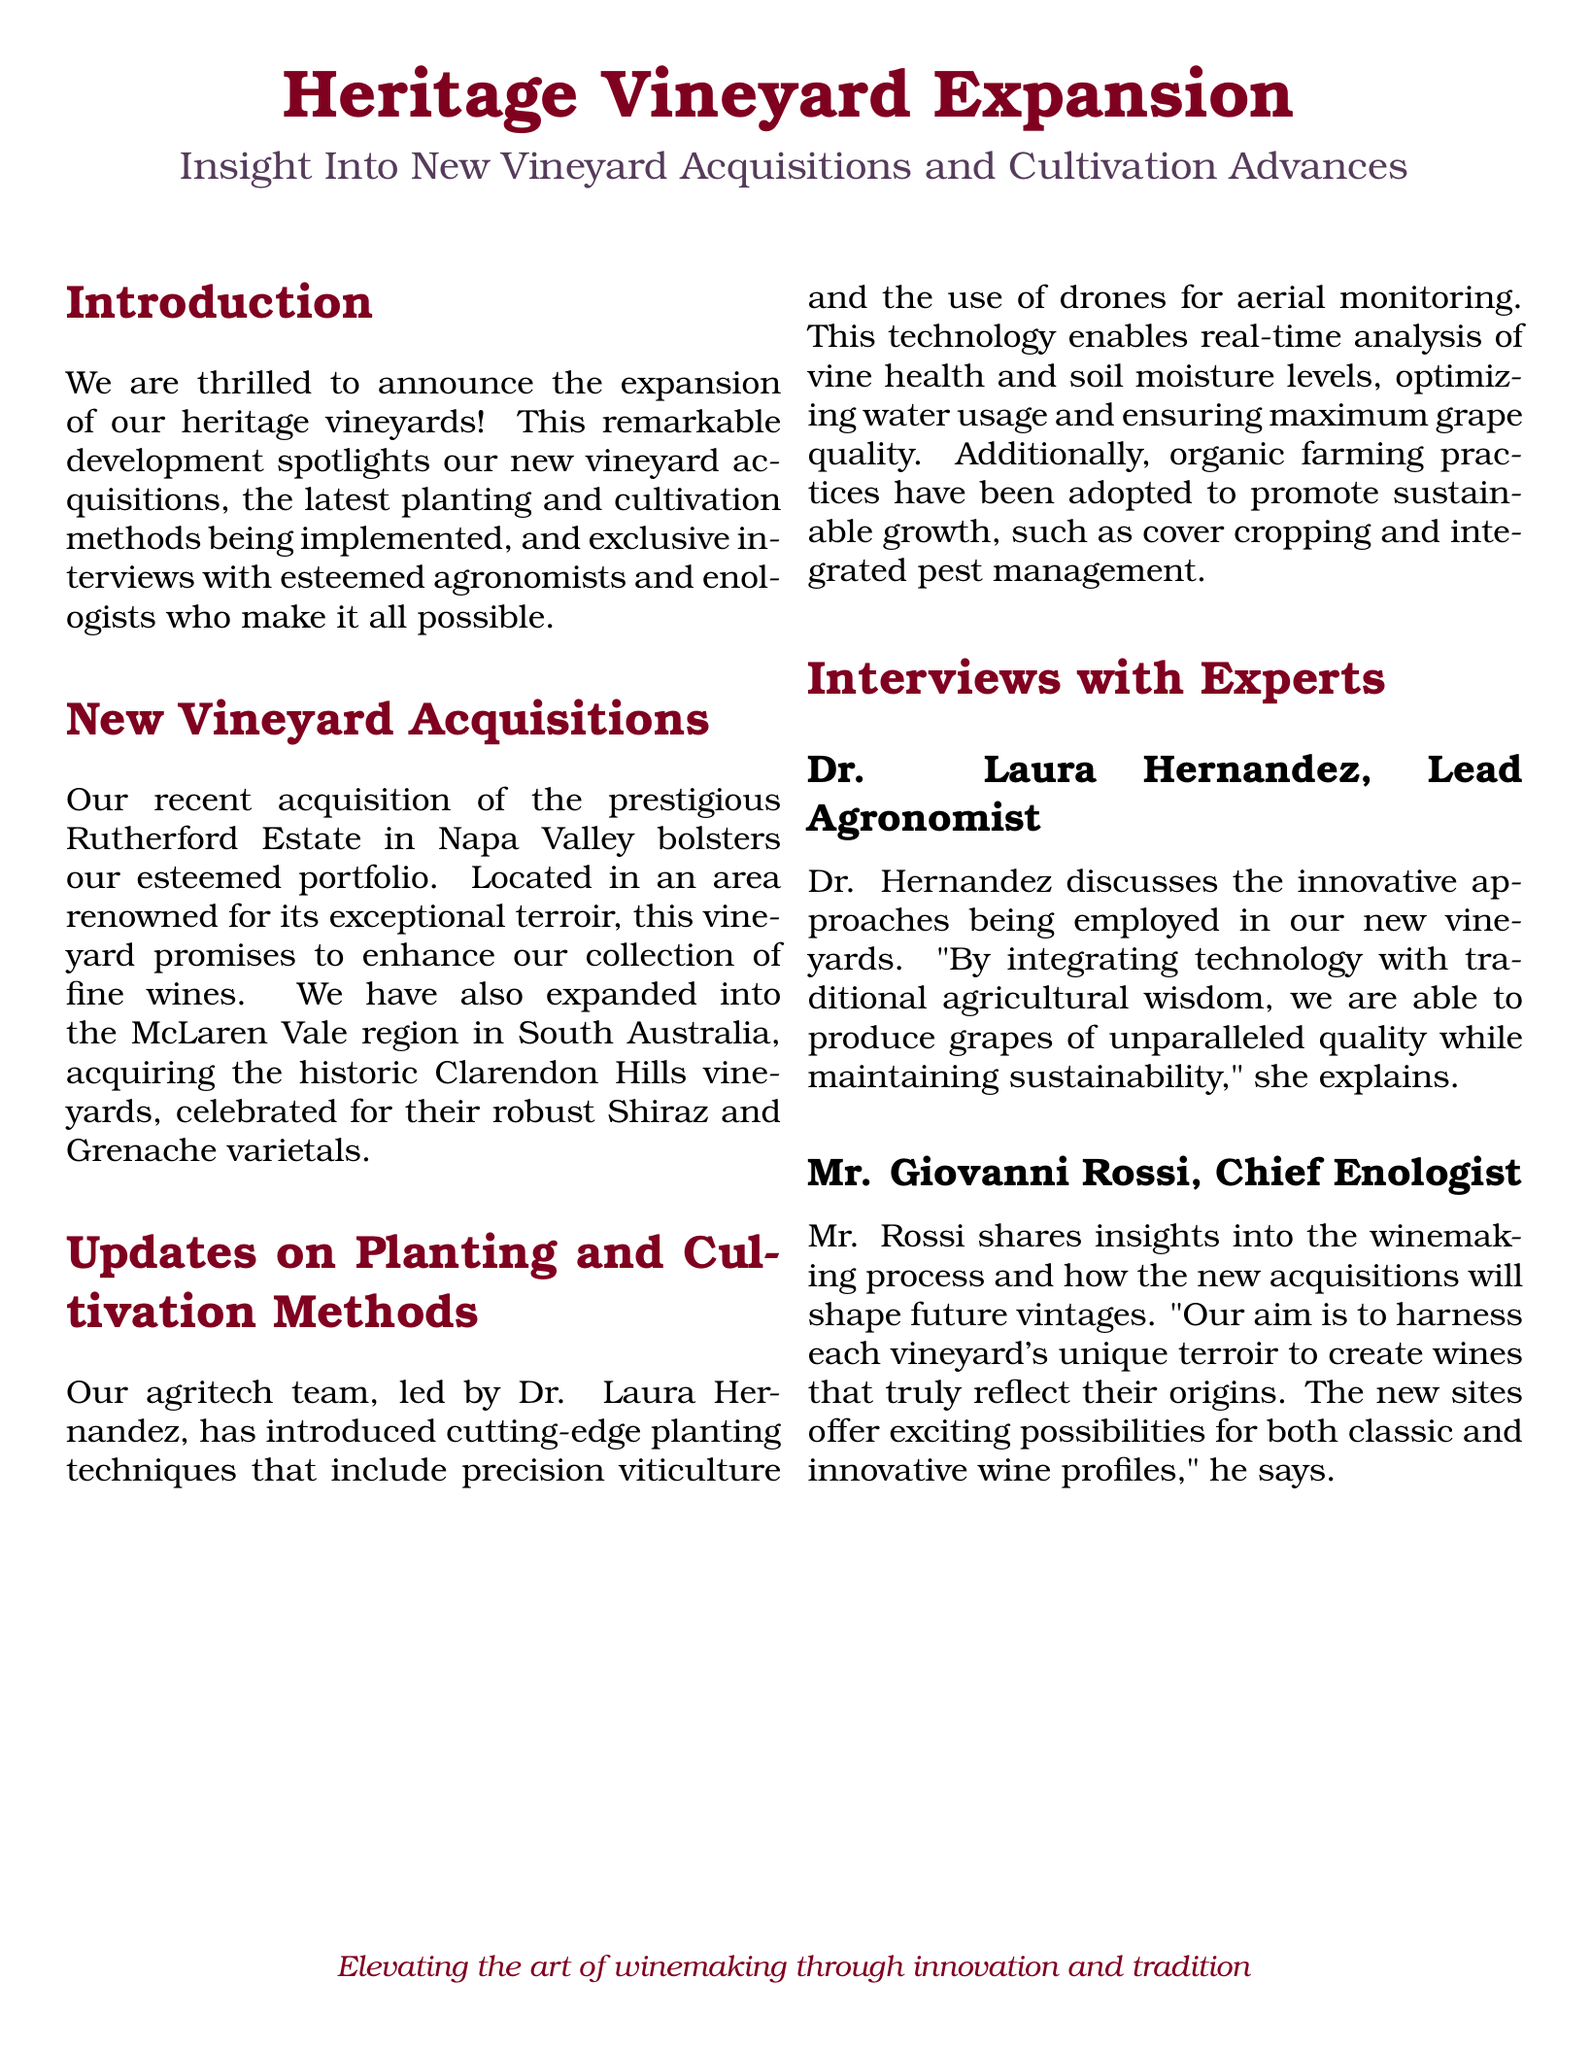What is the name of the recently acquired vineyard in Napa Valley? The document mentions the acquisition of the Rutherford Estate in Napa Valley.
Answer: Rutherford Estate Who is the Lead Agronomist mentioned in the document? The document identifies Dr. Laura Hernandez as the Lead Agronomist.
Answer: Dr. Laura Hernandez What farming practices have been adopted to promote sustainable growth? The document states that organic farming practices such as cover cropping and integrated pest management have been adopted.
Answer: Organic farming practices Which region is home to the newly acquired Clarendon Hills vineyards? The document states that the Clarendon Hills vineyards are located in the McLaren Vale region in South Australia.
Answer: McLaren Vale What technology is being used for aerial monitoring in the new vineyards? The document mentions the use of drones for aerial monitoring as part of the advanced techniques.
Answer: Drones What is the focus of Mr. Giovanni Rossi's insights in the document? Mr. Rossi's insights focus on how the new acquisitions will shape future vintages by harnessing each vineyard's unique terroir.
Answer: Unique terroir How does Dr. Hernandez describe the integration of technology and traditional methods? Dr. Hernandez explains that this integration allows for the production of grapes of unparalleled quality while maintaining sustainability.
Answer: Unparalleled quality What does the document highlight as the aim of the vineyard expansion? The aim is to elevate the art of winemaking through innovation and tradition.
Answer: Elevate the art of winemaking 